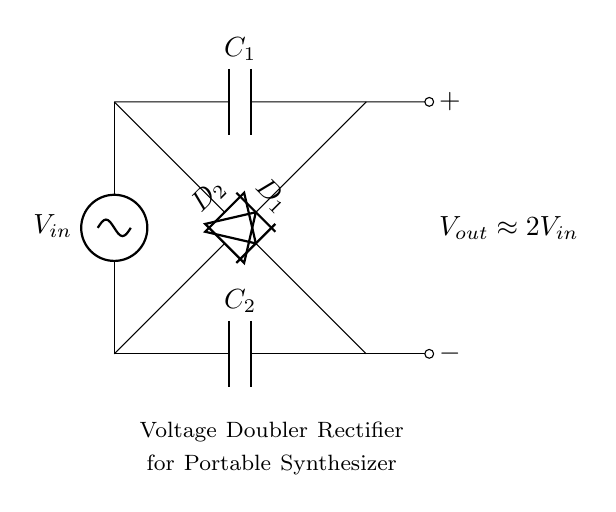What is the input voltage labeled as? The input voltage in the diagram is labeled as V-in, indicating the voltage that will be supplied to the rectifier circuit.
Answer: V-in What kind of diodes are used in this circuit? The circuit uses two diodes labeled D1 and D2, which are typically used in rectifier applications to convert AC to DC.
Answer: Diodes What does V-out approximate to? The V-out label indicates that the output voltage will be approximately double the input voltage, as this is a voltage doubler circuit.
Answer: 2V-in How many capacitors are present in the circuit? The diagram shows two capacitors, C1 and C2, which are necessary for smoothing the output voltage in the rectification process.
Answer: Two What is the function of the capacitors in this circuit? Capacitors C1 and C2 store charge during the rectification process, smoothing the output voltage and ensuring a more stable DC output.
Answer: Smoothing Why does this circuit double the voltage? The circuit doubles the voltage by using the arrangement of diodes and capacitors to recharge the capacitors to a higher voltage than the input, effectively multiplying the input voltage.
Answer: It uses diodes and capacitors 